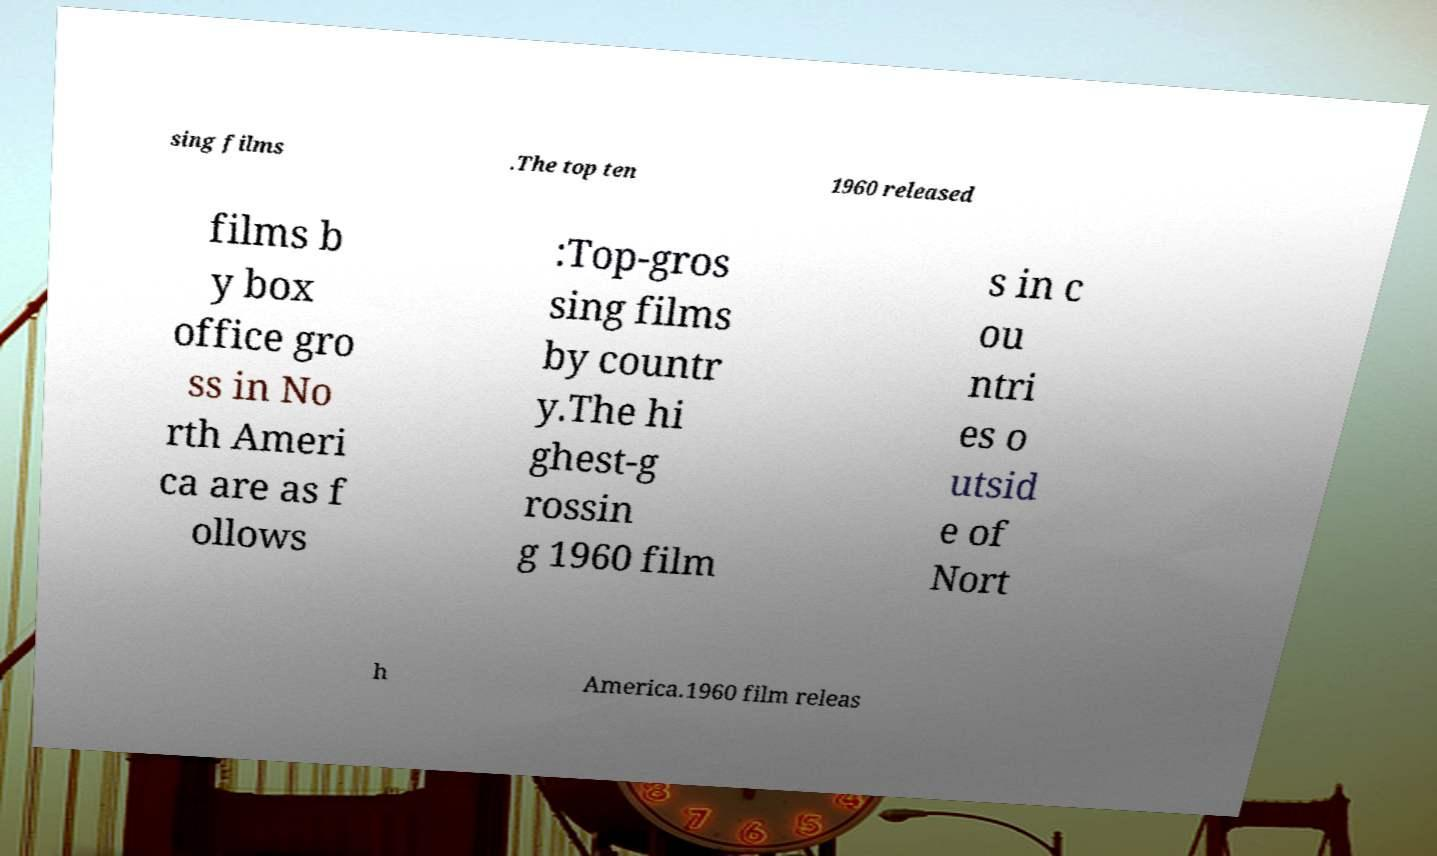Please identify and transcribe the text found in this image. sing films .The top ten 1960 released films b y box office gro ss in No rth Ameri ca are as f ollows :Top-gros sing films by countr y.The hi ghest-g rossin g 1960 film s in c ou ntri es o utsid e of Nort h America.1960 film releas 